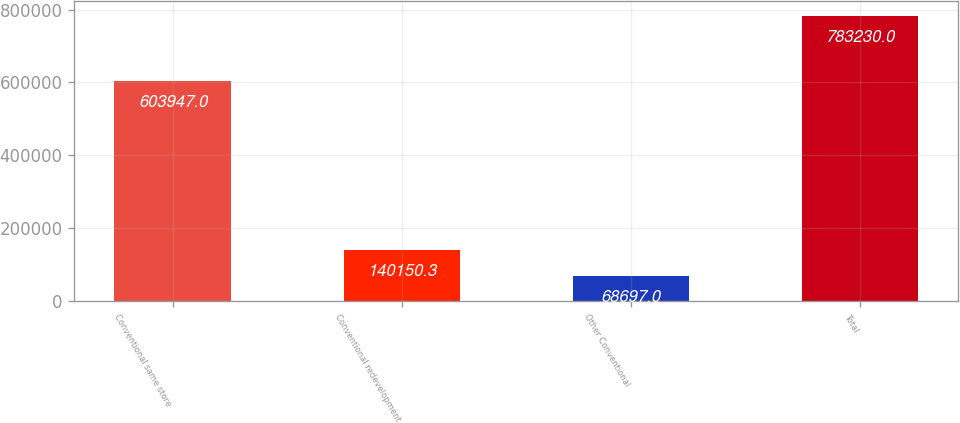<chart> <loc_0><loc_0><loc_500><loc_500><bar_chart><fcel>Conventional same store<fcel>Conventional redevelopment<fcel>Other Conventional<fcel>Total<nl><fcel>603947<fcel>140150<fcel>68697<fcel>783230<nl></chart> 